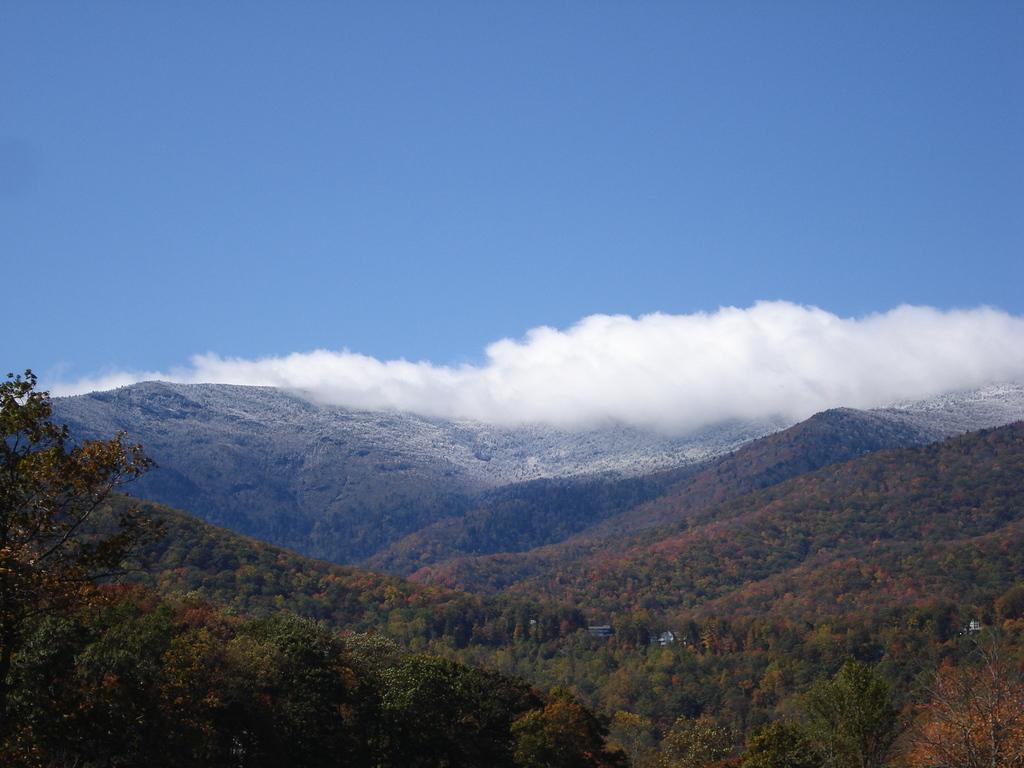Please provide a concise description of this image. In this picture we can see a few plants and houses. There are a few mountains visible in the background. Sky is blue in color and cloudy. 